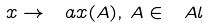Convert formula to latex. <formula><loc_0><loc_0><loc_500><loc_500>x \rightarrow \ a x ( A ) , \, A \in \ A l</formula> 